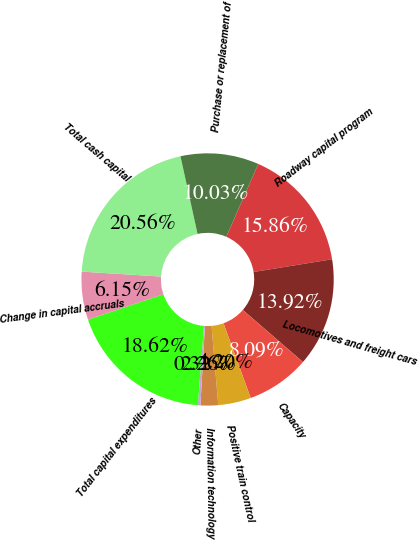Convert chart. <chart><loc_0><loc_0><loc_500><loc_500><pie_chart><fcel>Roadway capital program<fcel>Locomotives and freight cars<fcel>Capacity<fcel>Positive train control<fcel>Information technology<fcel>Other<fcel>Total capital expenditures<fcel>Change in capital accruals<fcel>Total cash capital<fcel>Purchase or replacement of<nl><fcel>15.86%<fcel>13.92%<fcel>8.09%<fcel>4.2%<fcel>2.26%<fcel>0.32%<fcel>18.62%<fcel>6.15%<fcel>20.56%<fcel>10.03%<nl></chart> 